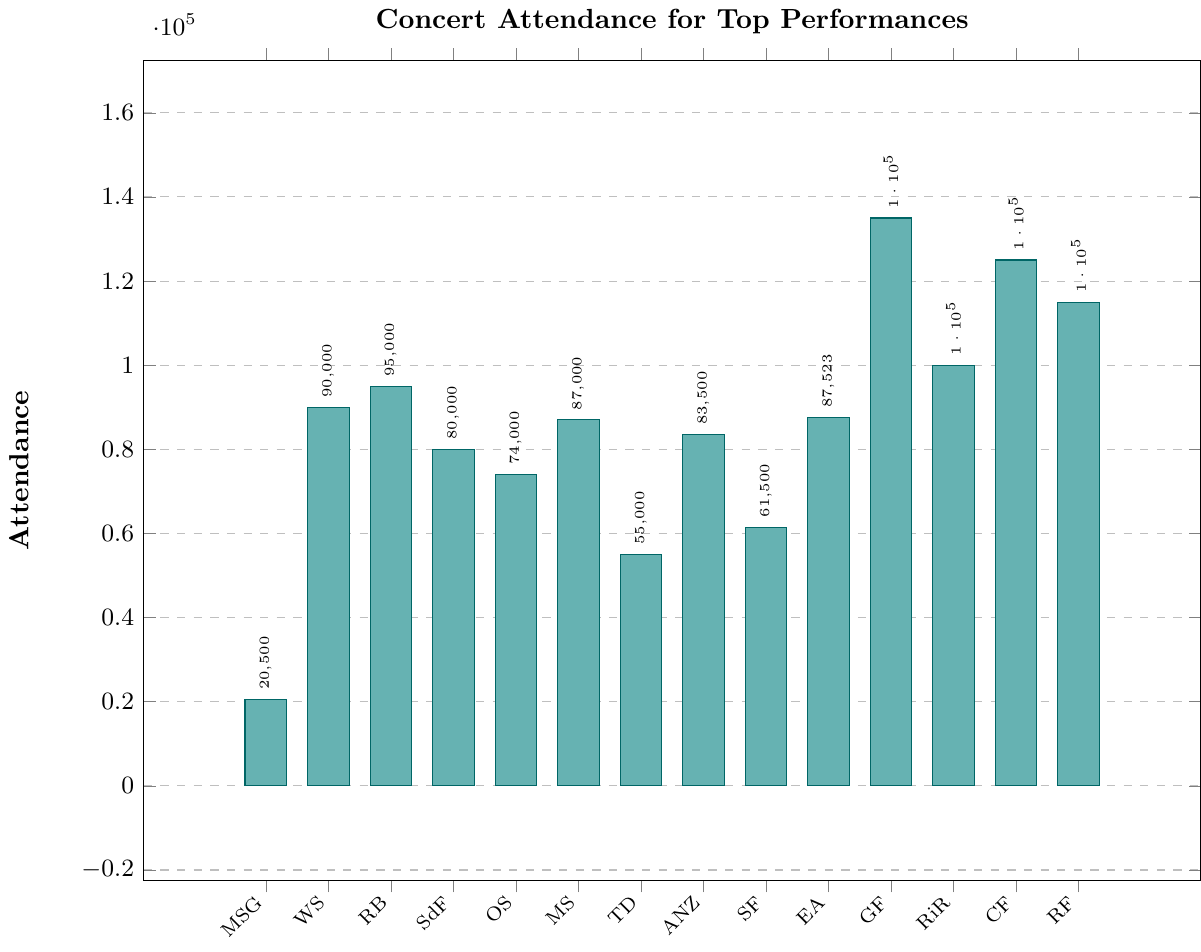What's the highest attendance figure among the venues? Look for the bar that reaches the highest point on the y-axis. Identify the venue associated with this bar by checking the x-axis label.
Answer: Glastonbury Festival (135,000) Which venue has the lowest attendance figure? Find the bar that is the shortest on the y-axis and check the corresponding x-axis label to identify the venue.
Answer: Madison Square Garden (20,500) How does the attendance at Wembley Stadium compare to that at Rose Bowl? Compare the heights of the bars for Wembley Stadium and Rose Bowl. Rose Bowl has a slightly higher bar than Wembley Stadium.
Answer: Rose Bowl > Wembley Stadium What is the total attendance of all performances combined? Add up all the attendance figures given in the bars: 20500 + 90000 + 95000 + 80000 + 74000 + 87000 + 55000 + 83500 + 61500 + 87523 + 135000 + 100000 + 125000 + 115000.
Answer: 1,191,023 How many venues have an attendance of 80,000 or more? Count the number of bars that reach or exceed the 80,000 mark on the y-axis.
Answer: 11 What is the difference in attendance figures between the Tokyo Dome and the Maracanã Stadium? Subtract the attendance for Tokyo Dome from the attendance for Maracanã Stadium (87,000 - 55,000).
Answer: 32,000 Which three venues have the highest attendance figures? Identify the top three tallest bars and their corresponding venues on the x-axis.
Answer: Glastonbury Festival, Coachella Festival, Rock in Rio What is the average attendance across all venues? Sum all the attendance figures and divide by the number of venues (14): (1,191,023 / 14).
Answer: 85,073 Is the attendance at Soldier Field greater or lesser than the attendance at ANZ Stadium? Compare the heights of the bars for Soldier Field and ANZ Stadium. ANZ Stadium has a higher bar than Soldier Field.
Answer: Soldier Field < ANZ Stadium What is the difference in attendance figures between the Rose Bowl and Stade de France combined with that at Glastonbury Festival? First, sum the attendance of Rose Bowl (95,000) and Stade de France (80,000): 95,000 + 80,000 = 175,000. Then subtract the attendance of Glastonbury Festival (135,000) from this sum: 175,000 - 135,000.
Answer: 40,000 